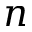Convert formula to latex. <formula><loc_0><loc_0><loc_500><loc_500>n</formula> 